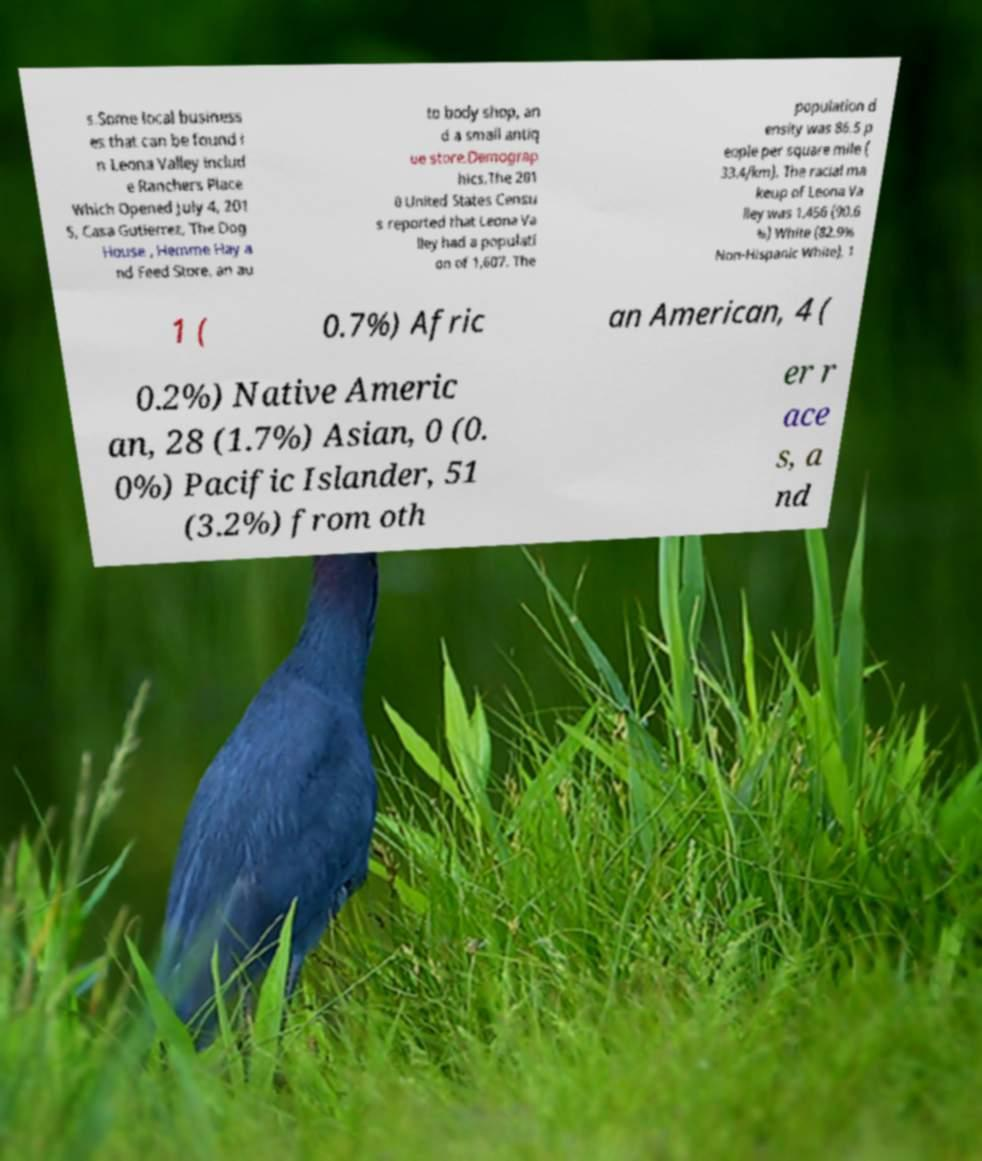Can you accurately transcribe the text from the provided image for me? s.Some local business es that can be found i n Leona Valley includ e Ranchers Place Which Opened July 4, 201 5, Casa Gutierrez, The Dog House , Hemme Hay a nd Feed Store, an au to body shop, an d a small antiq ue store.Demograp hics.The 201 0 United States Censu s reported that Leona Va lley had a populati on of 1,607. The population d ensity was 86.5 p eople per square mile ( 33.4/km). The racial ma keup of Leona Va lley was 1,456 (90.6 %) White (82.9% Non-Hispanic White), 1 1 ( 0.7%) Afric an American, 4 ( 0.2%) Native Americ an, 28 (1.7%) Asian, 0 (0. 0%) Pacific Islander, 51 (3.2%) from oth er r ace s, a nd 